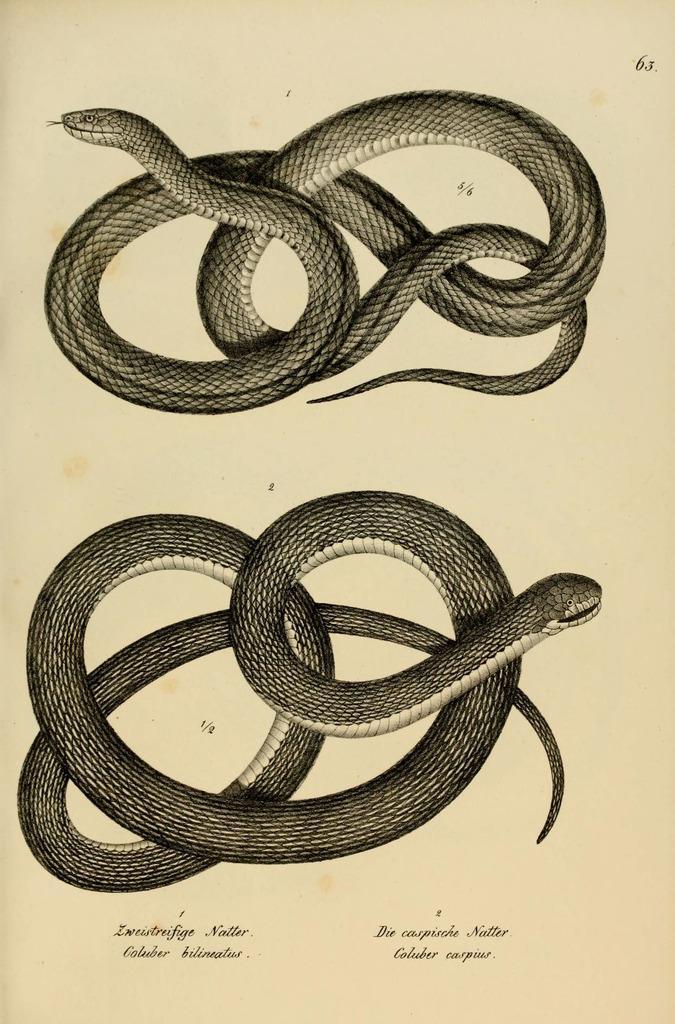Describe this image in one or two sentences. In this picture I can see the text at the bottom, in the middle there are images of the snakes. 